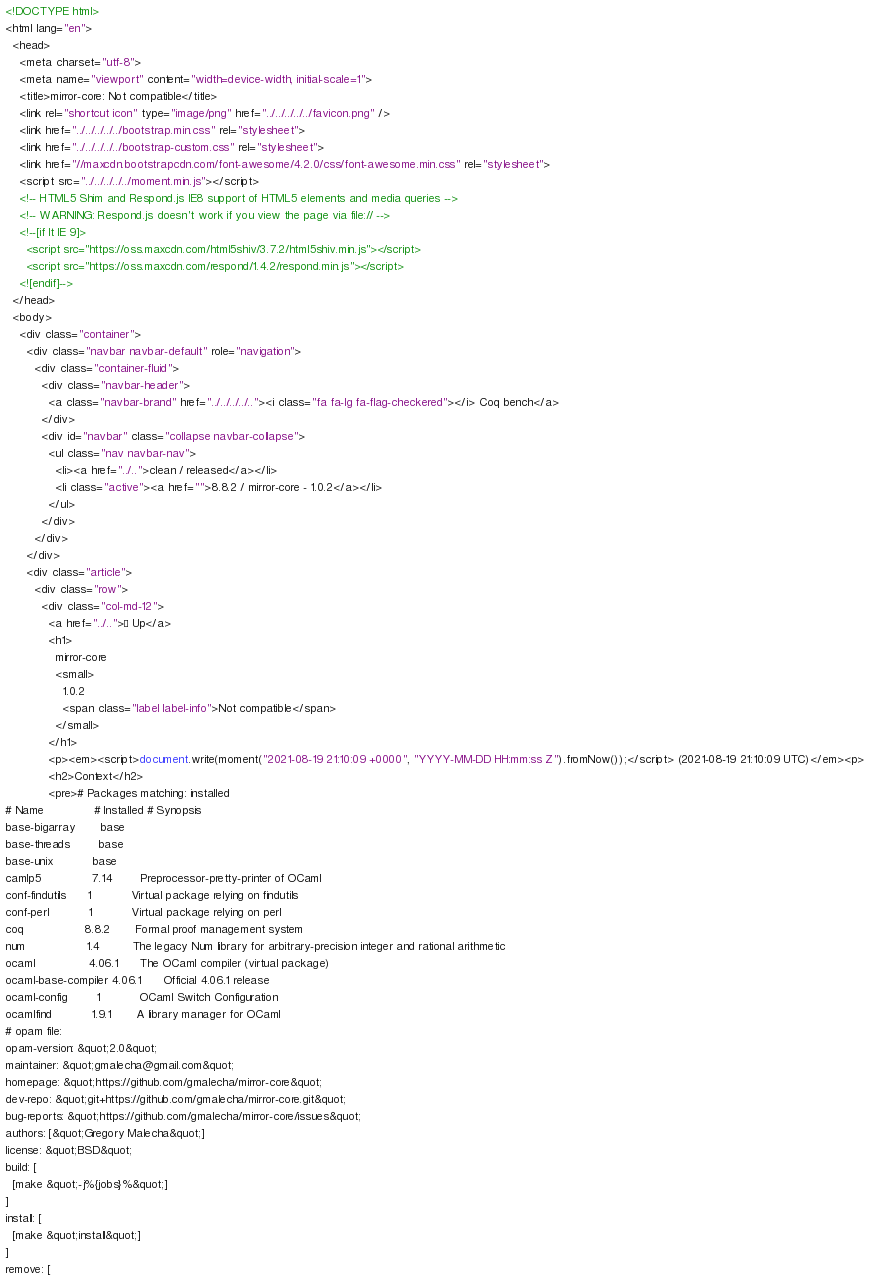<code> <loc_0><loc_0><loc_500><loc_500><_HTML_><!DOCTYPE html>
<html lang="en">
  <head>
    <meta charset="utf-8">
    <meta name="viewport" content="width=device-width, initial-scale=1">
    <title>mirror-core: Not compatible</title>
    <link rel="shortcut icon" type="image/png" href="../../../../../favicon.png" />
    <link href="../../../../../bootstrap.min.css" rel="stylesheet">
    <link href="../../../../../bootstrap-custom.css" rel="stylesheet">
    <link href="//maxcdn.bootstrapcdn.com/font-awesome/4.2.0/css/font-awesome.min.css" rel="stylesheet">
    <script src="../../../../../moment.min.js"></script>
    <!-- HTML5 Shim and Respond.js IE8 support of HTML5 elements and media queries -->
    <!-- WARNING: Respond.js doesn't work if you view the page via file:// -->
    <!--[if lt IE 9]>
      <script src="https://oss.maxcdn.com/html5shiv/3.7.2/html5shiv.min.js"></script>
      <script src="https://oss.maxcdn.com/respond/1.4.2/respond.min.js"></script>
    <![endif]-->
  </head>
  <body>
    <div class="container">
      <div class="navbar navbar-default" role="navigation">
        <div class="container-fluid">
          <div class="navbar-header">
            <a class="navbar-brand" href="../../../../.."><i class="fa fa-lg fa-flag-checkered"></i> Coq bench</a>
          </div>
          <div id="navbar" class="collapse navbar-collapse">
            <ul class="nav navbar-nav">
              <li><a href="../..">clean / released</a></li>
              <li class="active"><a href="">8.8.2 / mirror-core - 1.0.2</a></li>
            </ul>
          </div>
        </div>
      </div>
      <div class="article">
        <div class="row">
          <div class="col-md-12">
            <a href="../..">« Up</a>
            <h1>
              mirror-core
              <small>
                1.0.2
                <span class="label label-info">Not compatible</span>
              </small>
            </h1>
            <p><em><script>document.write(moment("2021-08-19 21:10:09 +0000", "YYYY-MM-DD HH:mm:ss Z").fromNow());</script> (2021-08-19 21:10:09 UTC)</em><p>
            <h2>Context</h2>
            <pre># Packages matching: installed
# Name              # Installed # Synopsis
base-bigarray       base
base-threads        base
base-unix           base
camlp5              7.14        Preprocessor-pretty-printer of OCaml
conf-findutils      1           Virtual package relying on findutils
conf-perl           1           Virtual package relying on perl
coq                 8.8.2       Formal proof management system
num                 1.4         The legacy Num library for arbitrary-precision integer and rational arithmetic
ocaml               4.06.1      The OCaml compiler (virtual package)
ocaml-base-compiler 4.06.1      Official 4.06.1 release
ocaml-config        1           OCaml Switch Configuration
ocamlfind           1.9.1       A library manager for OCaml
# opam file:
opam-version: &quot;2.0&quot;
maintainer: &quot;gmalecha@gmail.com&quot;
homepage: &quot;https://github.com/gmalecha/mirror-core&quot;
dev-repo: &quot;git+https://github.com/gmalecha/mirror-core.git&quot;
bug-reports: &quot;https://github.com/gmalecha/mirror-core/issues&quot;
authors: [&quot;Gregory Malecha&quot;]
license: &quot;BSD&quot;
build: [
  [make &quot;-j%{jobs}%&quot;]
]
install: [
  [make &quot;install&quot;]
]
remove: [</code> 